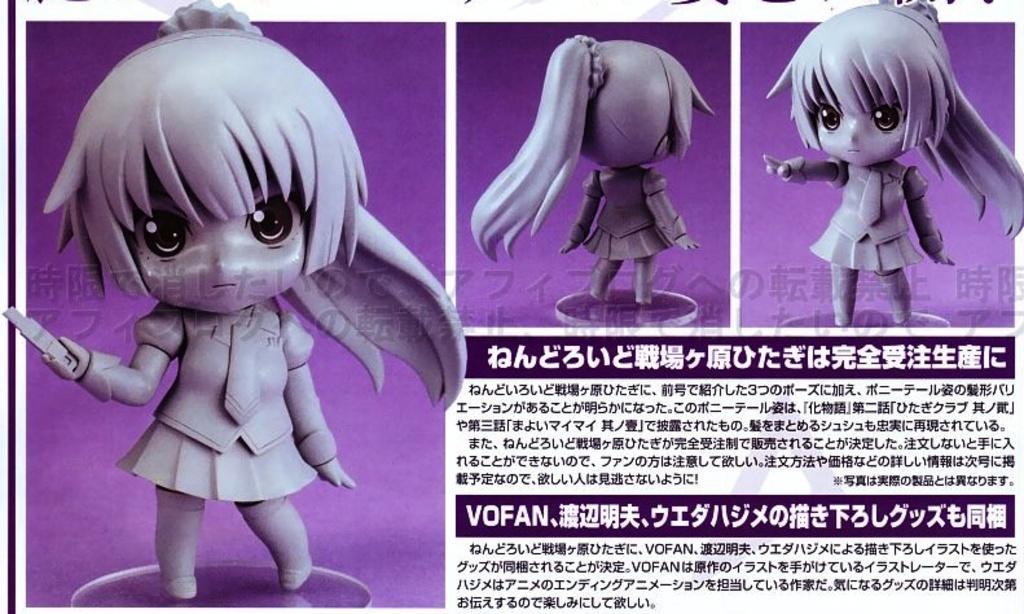Please provide a concise description of this image. In this image I can see few dolls and something is written on it. Background is in purple color and it looks like the collage image. 